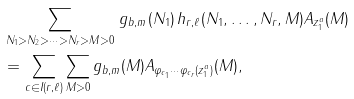Convert formula to latex. <formula><loc_0><loc_0><loc_500><loc_500>& \sum _ { N _ { 1 } > N _ { 2 } > \cdots > N _ { r } > M > 0 } \, g _ { b , m } ( N _ { 1 } ) \, h _ { r , \ell } ( N _ { 1 } , \dots , N _ { r } , M ) A _ { z _ { 1 } ^ { a } } ( M ) \\ & = \sum _ { c \in I ( r , \ell ) } \sum _ { M > 0 } g _ { b , m } ( M ) A _ { \varphi _ { c _ { 1 } } \cdots \varphi _ { c _ { r } } ( z _ { 1 } ^ { a } ) } ( M ) ,</formula> 